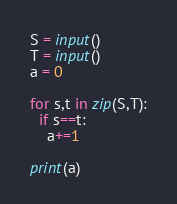<code> <loc_0><loc_0><loc_500><loc_500><_Python_>S = input()
T = input()
a = 0

for s,t in zip(S,T):
  if s==t:
    a+=1

print(a)</code> 